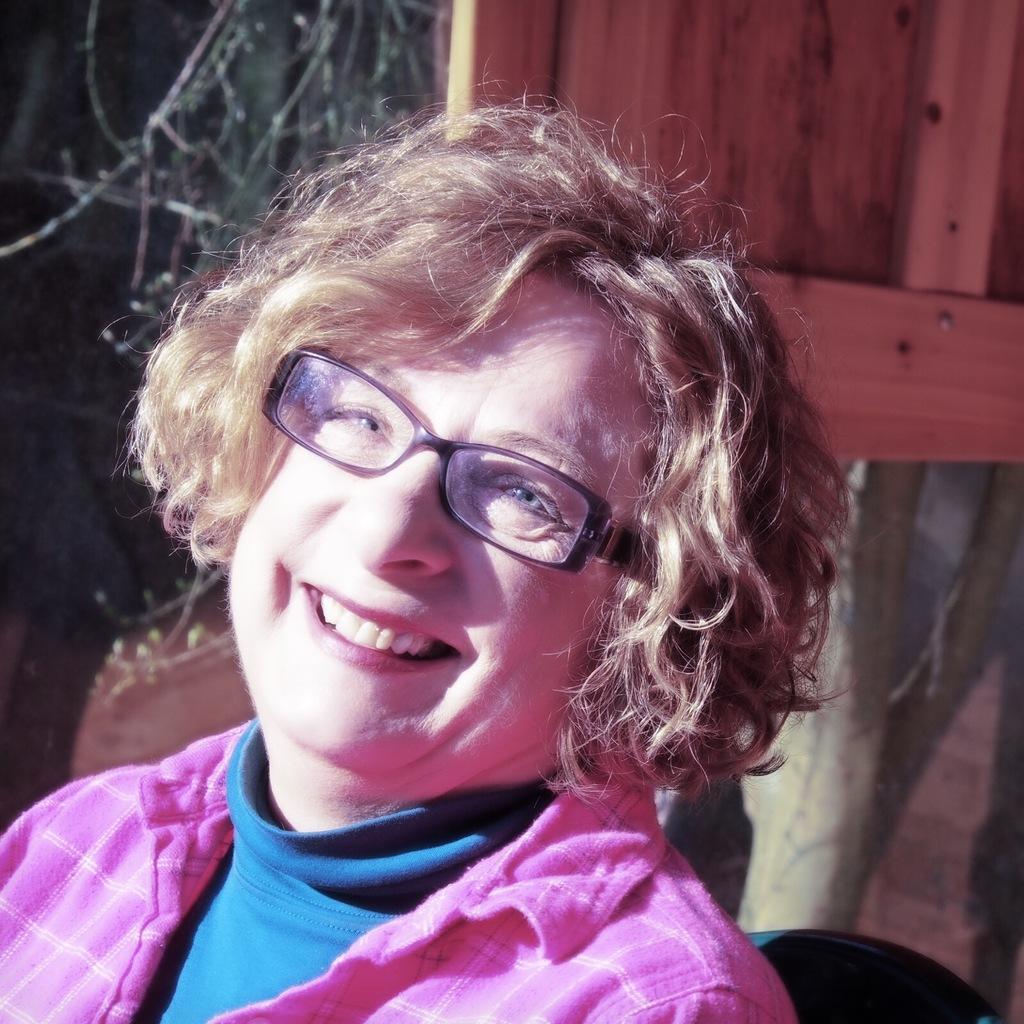How would you summarize this image in a sentence or two? In this image we can see a woman wearing specs. In the back there is a wooden object. Also there is a tree. 